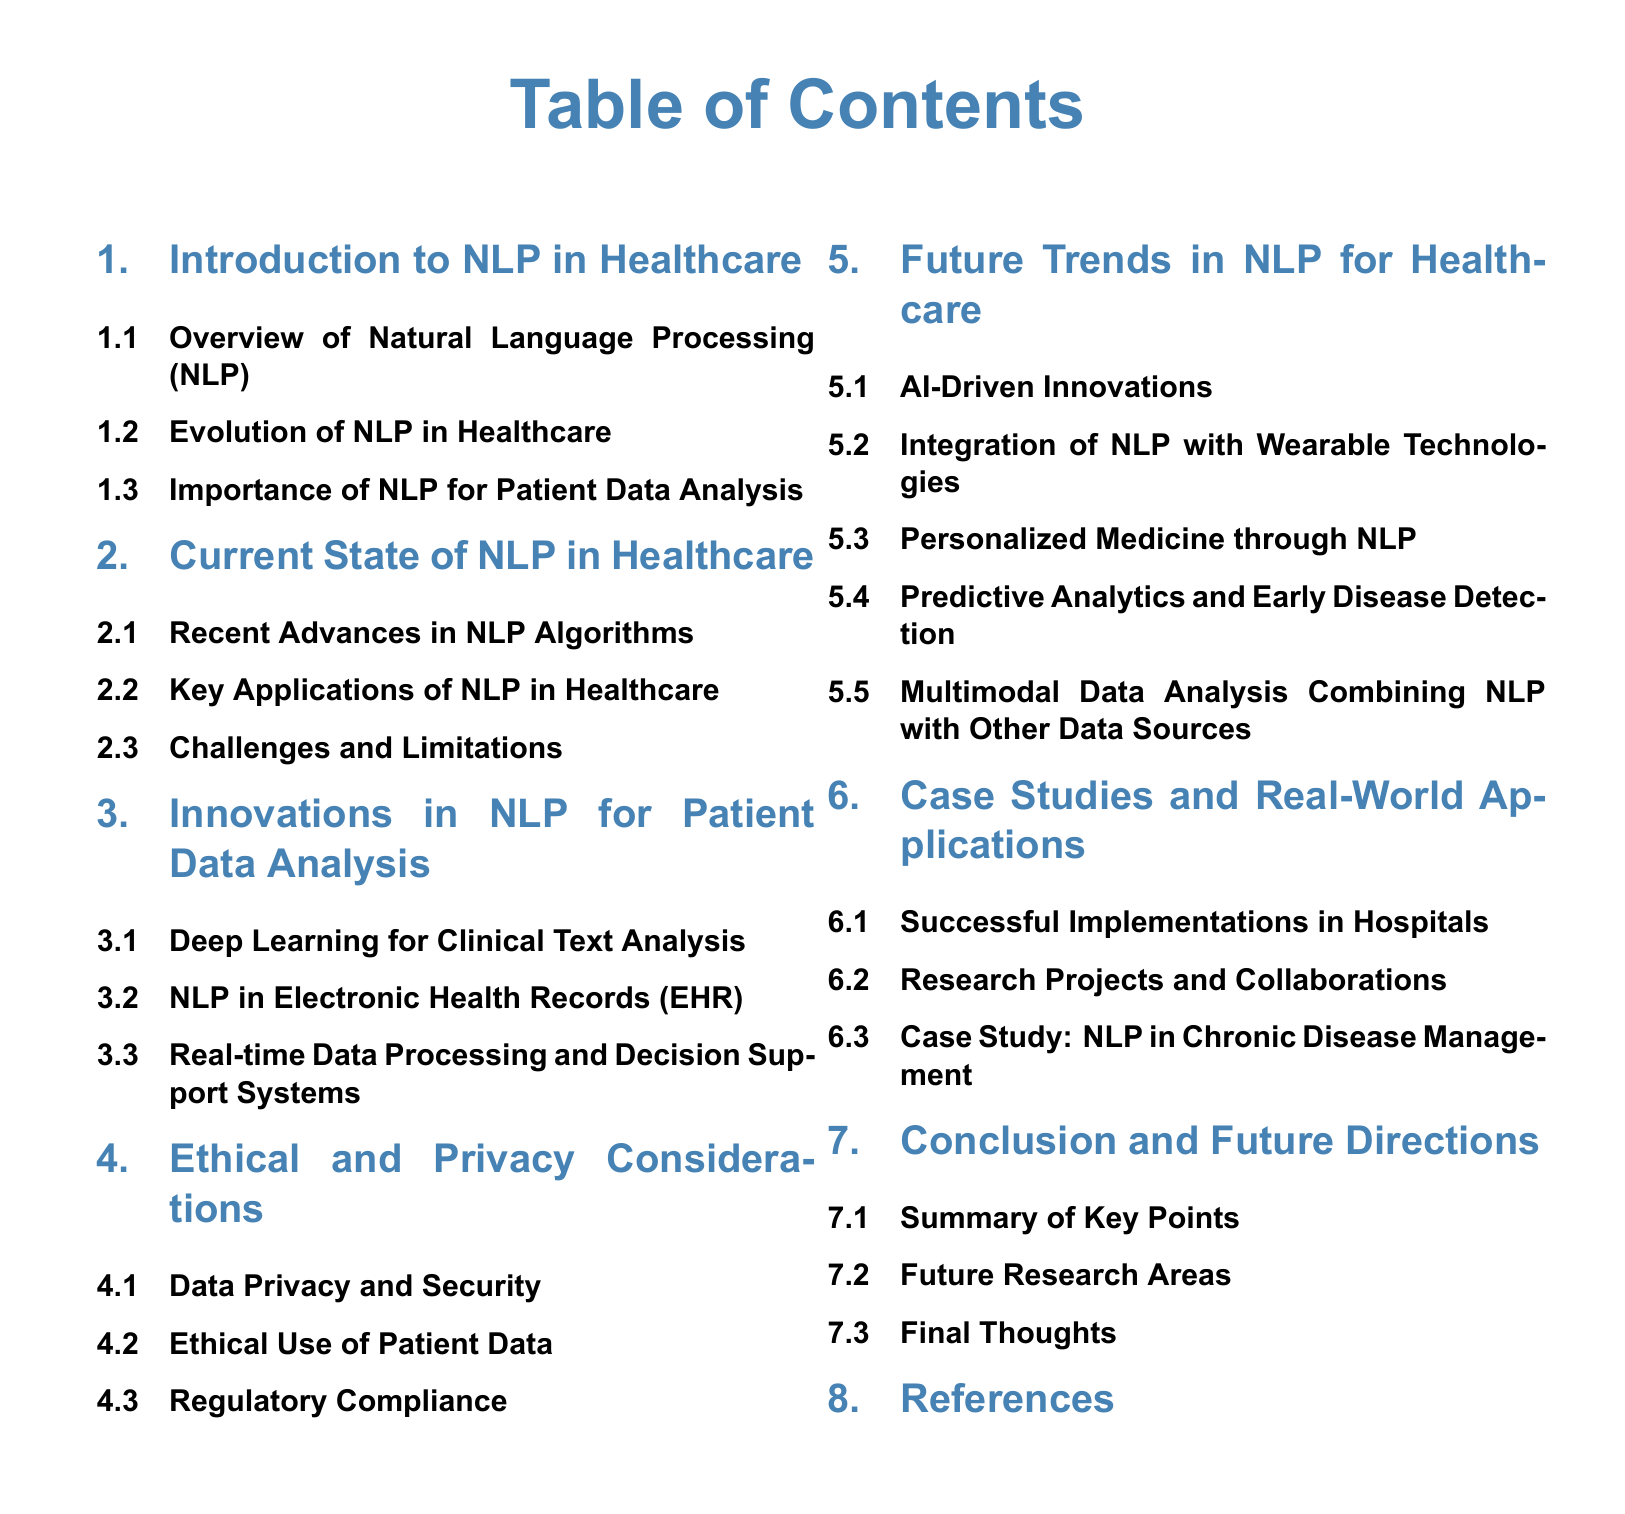What is the main topic of the document? The main topic is the future trends in NLP for healthcare, along with innovations and their impact.
Answer: Future Trends in NLP for Healthcare How many subsections are in the section "Future Trends in NLP for Healthcare"? The section contains five subsections, outlining various trends and innovations.
Answer: Five What technology integration is mentioned under "Future Trends in NLP for Healthcare"? The integration of NLP with wearable technologies is highlighted as a future trend.
Answer: Wearable Technologies What is one key application of NLP mentioned in the current state of healthcare? The document mentions several applications, with one being electronic health records.
Answer: Electronic Health Records Which section discusses ethical considerations? The section titled "Ethical and Privacy Considerations" specifically addresses ethical issues related to NLP.
Answer: Ethical and Privacy Considerations What type of analysis is suggested for combining different data sources in future NLP applications? Multimodal data analysis is proposed for effectively combining diverse data sources in future applications.
Answer: Multimodal Data Analysis What is the first subsection of the "Future Trends in NLP for Healthcare"? The first subsection focuses on AI-driven innovations that are expected to impact healthcare NLP.
Answer: AI-Driven Innovations Name one area of future research indicated in the conclusion section. The document suggests exploring future research areas and emphasizes the importance of ongoing studies.
Answer: Future Research Areas 